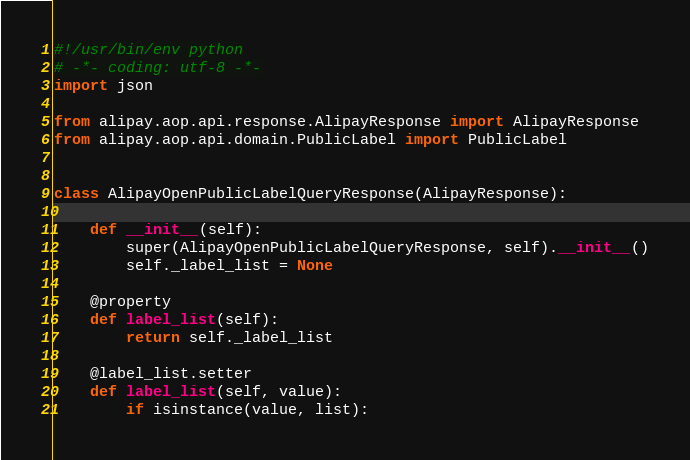<code> <loc_0><loc_0><loc_500><loc_500><_Python_>#!/usr/bin/env python
# -*- coding: utf-8 -*-
import json

from alipay.aop.api.response.AlipayResponse import AlipayResponse
from alipay.aop.api.domain.PublicLabel import PublicLabel


class AlipayOpenPublicLabelQueryResponse(AlipayResponse):

    def __init__(self):
        super(AlipayOpenPublicLabelQueryResponse, self).__init__()
        self._label_list = None

    @property
    def label_list(self):
        return self._label_list

    @label_list.setter
    def label_list(self, value):
        if isinstance(value, list):</code> 